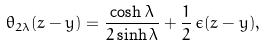Convert formula to latex. <formula><loc_0><loc_0><loc_500><loc_500>\theta _ { 2 \lambda } ( z - y ) = \frac { \cosh \lambda } { 2 \sinh \lambda } + \frac { 1 } { 2 } \, \epsilon ( z - y ) ,</formula> 